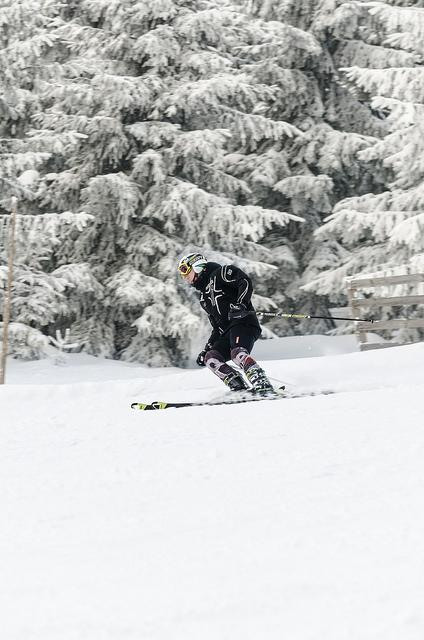Why do skiers wear suits? warmth 